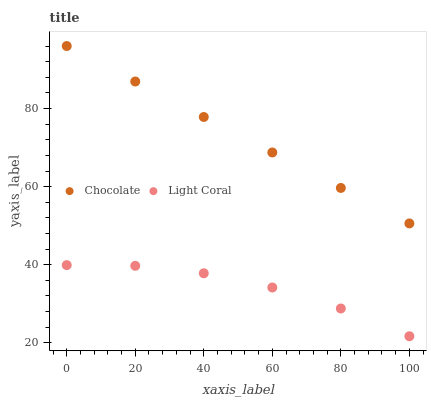Does Light Coral have the minimum area under the curve?
Answer yes or no. Yes. Does Chocolate have the maximum area under the curve?
Answer yes or no. Yes. Does Chocolate have the minimum area under the curve?
Answer yes or no. No. Is Chocolate the smoothest?
Answer yes or no. Yes. Is Light Coral the roughest?
Answer yes or no. Yes. Is Chocolate the roughest?
Answer yes or no. No. Does Light Coral have the lowest value?
Answer yes or no. Yes. Does Chocolate have the lowest value?
Answer yes or no. No. Does Chocolate have the highest value?
Answer yes or no. Yes. Is Light Coral less than Chocolate?
Answer yes or no. Yes. Is Chocolate greater than Light Coral?
Answer yes or no. Yes. Does Light Coral intersect Chocolate?
Answer yes or no. No. 